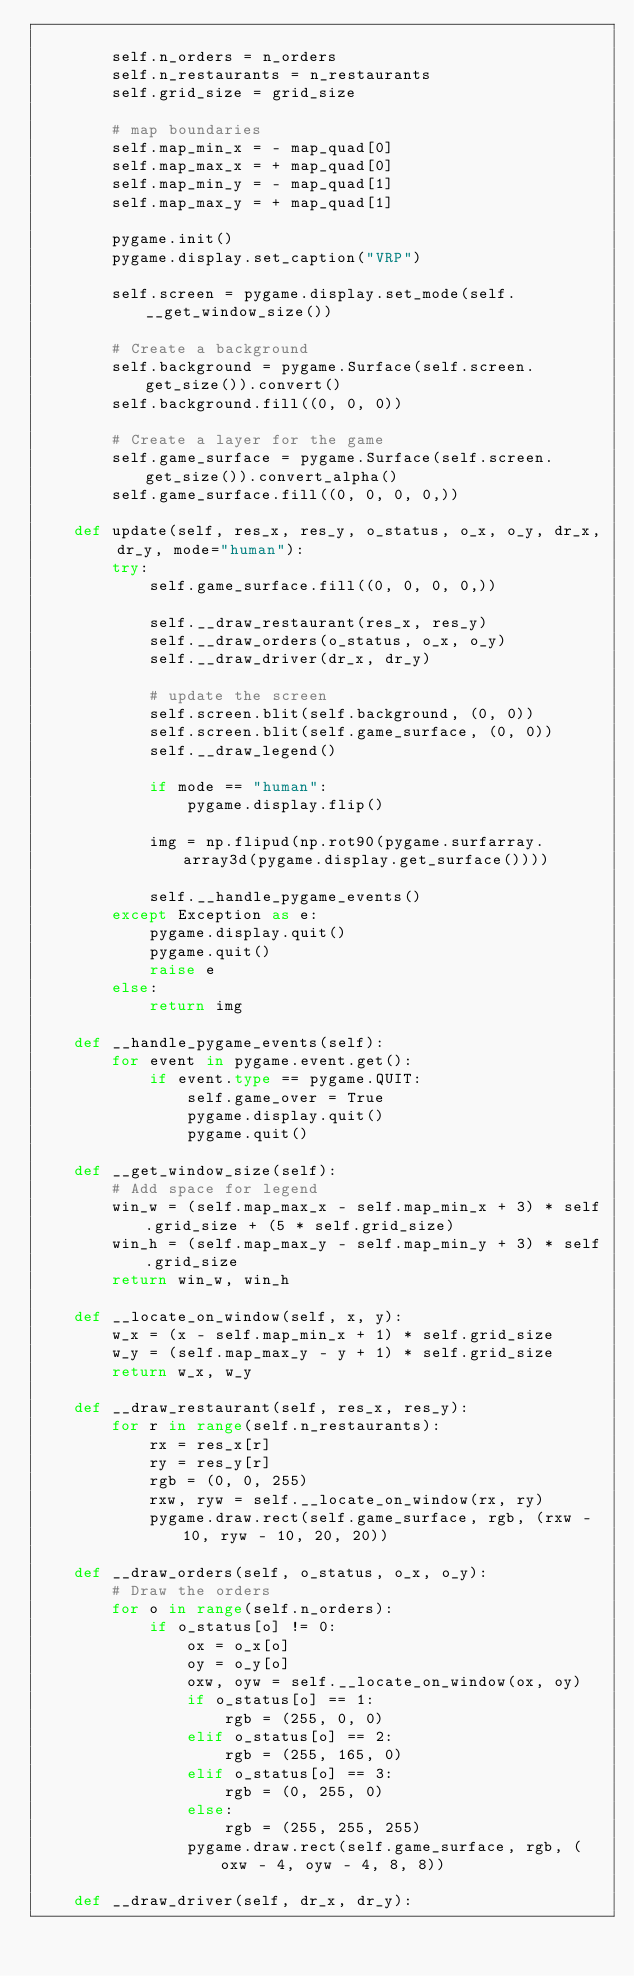<code> <loc_0><loc_0><loc_500><loc_500><_Python_>
        self.n_orders = n_orders
        self.n_restaurants = n_restaurants
        self.grid_size = grid_size

        # map boundaries
        self.map_min_x = - map_quad[0]
        self.map_max_x = + map_quad[0]
        self.map_min_y = - map_quad[1]
        self.map_max_y = + map_quad[1]

        pygame.init()
        pygame.display.set_caption("VRP")

        self.screen = pygame.display.set_mode(self.__get_window_size())

        # Create a background
        self.background = pygame.Surface(self.screen.get_size()).convert()
        self.background.fill((0, 0, 0))

        # Create a layer for the game
        self.game_surface = pygame.Surface(self.screen.get_size()).convert_alpha()
        self.game_surface.fill((0, 0, 0, 0,))

    def update(self, res_x, res_y, o_status, o_x, o_y, dr_x, dr_y, mode="human"):
        try:
            self.game_surface.fill((0, 0, 0, 0,))

            self.__draw_restaurant(res_x, res_y)
            self.__draw_orders(o_status, o_x, o_y)
            self.__draw_driver(dr_x, dr_y)

            # update the screen
            self.screen.blit(self.background, (0, 0))
            self.screen.blit(self.game_surface, (0, 0))
            self.__draw_legend()

            if mode == "human":
                pygame.display.flip()

            img = np.flipud(np.rot90(pygame.surfarray.array3d(pygame.display.get_surface())))

            self.__handle_pygame_events()
        except Exception as e:
            pygame.display.quit()
            pygame.quit()
            raise e
        else:
            return img

    def __handle_pygame_events(self):
        for event in pygame.event.get():
            if event.type == pygame.QUIT:
                self.game_over = True
                pygame.display.quit()
                pygame.quit()

    def __get_window_size(self):
        # Add space for legend
        win_w = (self.map_max_x - self.map_min_x + 3) * self.grid_size + (5 * self.grid_size)
        win_h = (self.map_max_y - self.map_min_y + 3) * self.grid_size
        return win_w, win_h

    def __locate_on_window(self, x, y):
        w_x = (x - self.map_min_x + 1) * self.grid_size
        w_y = (self.map_max_y - y + 1) * self.grid_size
        return w_x, w_y

    def __draw_restaurant(self, res_x, res_y):
        for r in range(self.n_restaurants):
            rx = res_x[r]
            ry = res_y[r]
            rgb = (0, 0, 255)
            rxw, ryw = self.__locate_on_window(rx, ry)
            pygame.draw.rect(self.game_surface, rgb, (rxw - 10, ryw - 10, 20, 20))

    def __draw_orders(self, o_status, o_x, o_y):
        # Draw the orders
        for o in range(self.n_orders):
            if o_status[o] != 0:
                ox = o_x[o]
                oy = o_y[o]
                oxw, oyw = self.__locate_on_window(ox, oy)
                if o_status[o] == 1:
                    rgb = (255, 0, 0)
                elif o_status[o] == 2:
                    rgb = (255, 165, 0)
                elif o_status[o] == 3:
                    rgb = (0, 255, 0)
                else:
                    rgb = (255, 255, 255)
                pygame.draw.rect(self.game_surface, rgb, (oxw - 4, oyw - 4, 8, 8))

    def __draw_driver(self, dr_x, dr_y):</code> 